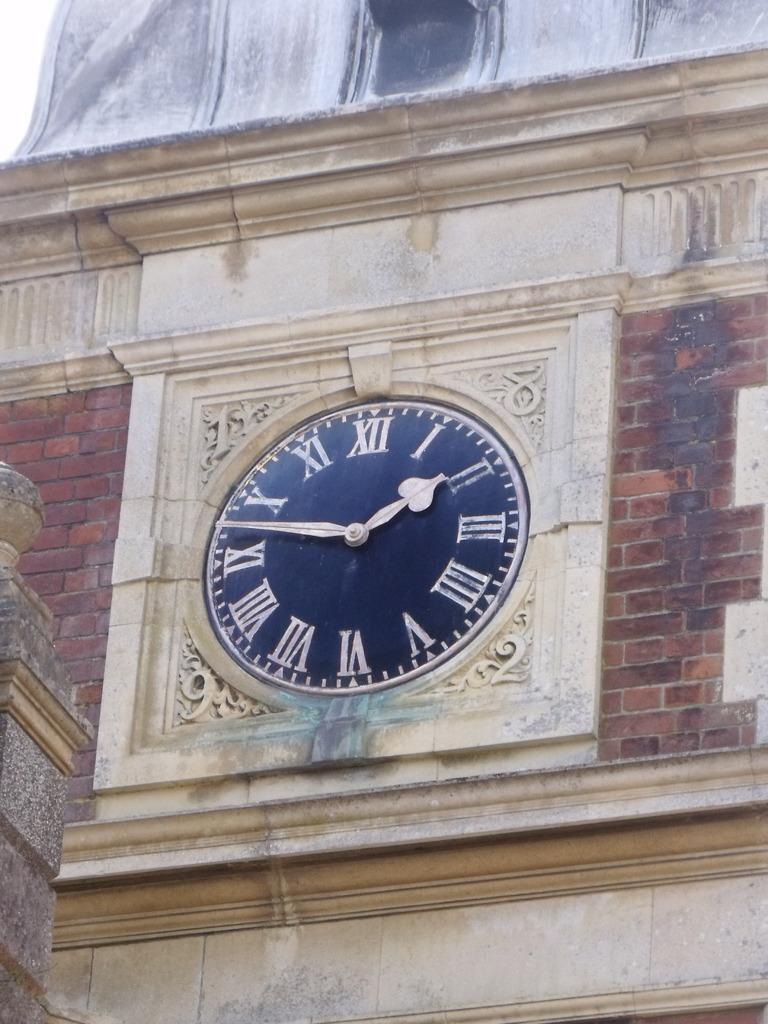How would you summarize this image in a sentence or two? Here we can see a clock on the wall and the bricks are red in color. 